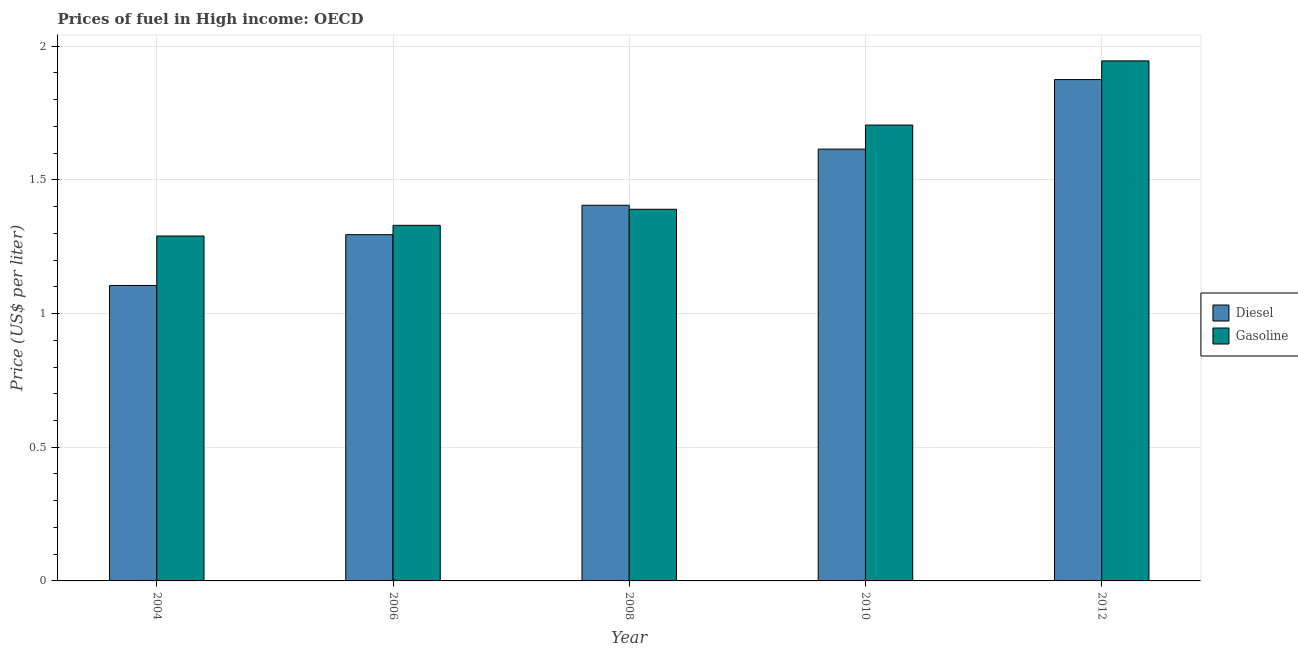How many different coloured bars are there?
Provide a short and direct response. 2. Are the number of bars per tick equal to the number of legend labels?
Your answer should be very brief. Yes. Are the number of bars on each tick of the X-axis equal?
Your answer should be very brief. Yes. How many bars are there on the 3rd tick from the left?
Offer a very short reply. 2. How many bars are there on the 2nd tick from the right?
Your answer should be compact. 2. What is the label of the 2nd group of bars from the left?
Your answer should be very brief. 2006. What is the diesel price in 2004?
Offer a terse response. 1.1. Across all years, what is the maximum gasoline price?
Provide a short and direct response. 1.95. Across all years, what is the minimum gasoline price?
Your answer should be compact. 1.29. In which year was the diesel price minimum?
Keep it short and to the point. 2004. What is the total diesel price in the graph?
Your response must be concise. 7.29. What is the difference between the diesel price in 2006 and that in 2010?
Offer a terse response. -0.32. What is the difference between the diesel price in 2006 and the gasoline price in 2008?
Your answer should be compact. -0.11. What is the average diesel price per year?
Your answer should be compact. 1.46. In the year 2010, what is the difference between the gasoline price and diesel price?
Keep it short and to the point. 0. What is the ratio of the diesel price in 2004 to that in 2006?
Ensure brevity in your answer.  0.85. What is the difference between the highest and the second highest gasoline price?
Provide a succinct answer. 0.24. What is the difference between the highest and the lowest diesel price?
Offer a very short reply. 0.77. In how many years, is the diesel price greater than the average diesel price taken over all years?
Provide a succinct answer. 2. Is the sum of the diesel price in 2008 and 2012 greater than the maximum gasoline price across all years?
Offer a terse response. Yes. What does the 1st bar from the left in 2012 represents?
Offer a terse response. Diesel. What does the 2nd bar from the right in 2006 represents?
Your response must be concise. Diesel. How many bars are there?
Your answer should be compact. 10. Are all the bars in the graph horizontal?
Your response must be concise. No. Does the graph contain any zero values?
Make the answer very short. No. Where does the legend appear in the graph?
Keep it short and to the point. Center right. How are the legend labels stacked?
Provide a succinct answer. Vertical. What is the title of the graph?
Offer a terse response. Prices of fuel in High income: OECD. Does "Crop" appear as one of the legend labels in the graph?
Make the answer very short. No. What is the label or title of the Y-axis?
Your response must be concise. Price (US$ per liter). What is the Price (US$ per liter) in Diesel in 2004?
Provide a short and direct response. 1.1. What is the Price (US$ per liter) of Gasoline in 2004?
Offer a very short reply. 1.29. What is the Price (US$ per liter) of Diesel in 2006?
Your response must be concise. 1.29. What is the Price (US$ per liter) of Gasoline in 2006?
Provide a succinct answer. 1.33. What is the Price (US$ per liter) of Diesel in 2008?
Keep it short and to the point. 1.41. What is the Price (US$ per liter) of Gasoline in 2008?
Provide a succinct answer. 1.39. What is the Price (US$ per liter) of Diesel in 2010?
Give a very brief answer. 1.61. What is the Price (US$ per liter) of Gasoline in 2010?
Your response must be concise. 1.71. What is the Price (US$ per liter) of Diesel in 2012?
Offer a terse response. 1.88. What is the Price (US$ per liter) of Gasoline in 2012?
Offer a terse response. 1.95. Across all years, what is the maximum Price (US$ per liter) of Diesel?
Give a very brief answer. 1.88. Across all years, what is the maximum Price (US$ per liter) in Gasoline?
Offer a very short reply. 1.95. Across all years, what is the minimum Price (US$ per liter) in Diesel?
Ensure brevity in your answer.  1.1. Across all years, what is the minimum Price (US$ per liter) of Gasoline?
Make the answer very short. 1.29. What is the total Price (US$ per liter) in Diesel in the graph?
Your answer should be very brief. 7.29. What is the total Price (US$ per liter) in Gasoline in the graph?
Give a very brief answer. 7.66. What is the difference between the Price (US$ per liter) in Diesel in 2004 and that in 2006?
Provide a short and direct response. -0.19. What is the difference between the Price (US$ per liter) in Gasoline in 2004 and that in 2006?
Keep it short and to the point. -0.04. What is the difference between the Price (US$ per liter) in Diesel in 2004 and that in 2008?
Provide a succinct answer. -0.3. What is the difference between the Price (US$ per liter) in Diesel in 2004 and that in 2010?
Make the answer very short. -0.51. What is the difference between the Price (US$ per liter) of Gasoline in 2004 and that in 2010?
Keep it short and to the point. -0.41. What is the difference between the Price (US$ per liter) in Diesel in 2004 and that in 2012?
Offer a very short reply. -0.77. What is the difference between the Price (US$ per liter) of Gasoline in 2004 and that in 2012?
Your answer should be very brief. -0.66. What is the difference between the Price (US$ per liter) in Diesel in 2006 and that in 2008?
Make the answer very short. -0.11. What is the difference between the Price (US$ per liter) of Gasoline in 2006 and that in 2008?
Your answer should be compact. -0.06. What is the difference between the Price (US$ per liter) in Diesel in 2006 and that in 2010?
Ensure brevity in your answer.  -0.32. What is the difference between the Price (US$ per liter) in Gasoline in 2006 and that in 2010?
Offer a terse response. -0.38. What is the difference between the Price (US$ per liter) in Diesel in 2006 and that in 2012?
Provide a succinct answer. -0.58. What is the difference between the Price (US$ per liter) of Gasoline in 2006 and that in 2012?
Your answer should be compact. -0.61. What is the difference between the Price (US$ per liter) in Diesel in 2008 and that in 2010?
Give a very brief answer. -0.21. What is the difference between the Price (US$ per liter) in Gasoline in 2008 and that in 2010?
Make the answer very short. -0.32. What is the difference between the Price (US$ per liter) in Diesel in 2008 and that in 2012?
Keep it short and to the point. -0.47. What is the difference between the Price (US$ per liter) of Gasoline in 2008 and that in 2012?
Your answer should be very brief. -0.56. What is the difference between the Price (US$ per liter) of Diesel in 2010 and that in 2012?
Ensure brevity in your answer.  -0.26. What is the difference between the Price (US$ per liter) in Gasoline in 2010 and that in 2012?
Keep it short and to the point. -0.24. What is the difference between the Price (US$ per liter) in Diesel in 2004 and the Price (US$ per liter) in Gasoline in 2006?
Give a very brief answer. -0.23. What is the difference between the Price (US$ per liter) in Diesel in 2004 and the Price (US$ per liter) in Gasoline in 2008?
Give a very brief answer. -0.28. What is the difference between the Price (US$ per liter) in Diesel in 2004 and the Price (US$ per liter) in Gasoline in 2012?
Offer a very short reply. -0.84. What is the difference between the Price (US$ per liter) of Diesel in 2006 and the Price (US$ per liter) of Gasoline in 2008?
Offer a terse response. -0.1. What is the difference between the Price (US$ per liter) of Diesel in 2006 and the Price (US$ per liter) of Gasoline in 2010?
Your answer should be compact. -0.41. What is the difference between the Price (US$ per liter) in Diesel in 2006 and the Price (US$ per liter) in Gasoline in 2012?
Provide a short and direct response. -0.65. What is the difference between the Price (US$ per liter) in Diesel in 2008 and the Price (US$ per liter) in Gasoline in 2010?
Provide a succinct answer. -0.3. What is the difference between the Price (US$ per liter) of Diesel in 2008 and the Price (US$ per liter) of Gasoline in 2012?
Your response must be concise. -0.54. What is the difference between the Price (US$ per liter) of Diesel in 2010 and the Price (US$ per liter) of Gasoline in 2012?
Your response must be concise. -0.33. What is the average Price (US$ per liter) of Diesel per year?
Ensure brevity in your answer.  1.46. What is the average Price (US$ per liter) of Gasoline per year?
Keep it short and to the point. 1.53. In the year 2004, what is the difference between the Price (US$ per liter) of Diesel and Price (US$ per liter) of Gasoline?
Ensure brevity in your answer.  -0.18. In the year 2006, what is the difference between the Price (US$ per liter) of Diesel and Price (US$ per liter) of Gasoline?
Your response must be concise. -0.04. In the year 2008, what is the difference between the Price (US$ per liter) of Diesel and Price (US$ per liter) of Gasoline?
Offer a terse response. 0.01. In the year 2010, what is the difference between the Price (US$ per liter) in Diesel and Price (US$ per liter) in Gasoline?
Your response must be concise. -0.09. In the year 2012, what is the difference between the Price (US$ per liter) of Diesel and Price (US$ per liter) of Gasoline?
Offer a very short reply. -0.07. What is the ratio of the Price (US$ per liter) in Diesel in 2004 to that in 2006?
Offer a terse response. 0.85. What is the ratio of the Price (US$ per liter) in Gasoline in 2004 to that in 2006?
Offer a terse response. 0.97. What is the ratio of the Price (US$ per liter) in Diesel in 2004 to that in 2008?
Your answer should be compact. 0.79. What is the ratio of the Price (US$ per liter) of Gasoline in 2004 to that in 2008?
Your answer should be very brief. 0.93. What is the ratio of the Price (US$ per liter) in Diesel in 2004 to that in 2010?
Your answer should be compact. 0.68. What is the ratio of the Price (US$ per liter) of Gasoline in 2004 to that in 2010?
Keep it short and to the point. 0.76. What is the ratio of the Price (US$ per liter) of Diesel in 2004 to that in 2012?
Offer a terse response. 0.59. What is the ratio of the Price (US$ per liter) in Gasoline in 2004 to that in 2012?
Offer a terse response. 0.66. What is the ratio of the Price (US$ per liter) of Diesel in 2006 to that in 2008?
Offer a terse response. 0.92. What is the ratio of the Price (US$ per liter) of Gasoline in 2006 to that in 2008?
Keep it short and to the point. 0.96. What is the ratio of the Price (US$ per liter) in Diesel in 2006 to that in 2010?
Give a very brief answer. 0.8. What is the ratio of the Price (US$ per liter) in Gasoline in 2006 to that in 2010?
Keep it short and to the point. 0.78. What is the ratio of the Price (US$ per liter) of Diesel in 2006 to that in 2012?
Your answer should be compact. 0.69. What is the ratio of the Price (US$ per liter) of Gasoline in 2006 to that in 2012?
Give a very brief answer. 0.68. What is the ratio of the Price (US$ per liter) in Diesel in 2008 to that in 2010?
Provide a succinct answer. 0.87. What is the ratio of the Price (US$ per liter) of Gasoline in 2008 to that in 2010?
Give a very brief answer. 0.82. What is the ratio of the Price (US$ per liter) in Diesel in 2008 to that in 2012?
Provide a short and direct response. 0.75. What is the ratio of the Price (US$ per liter) of Gasoline in 2008 to that in 2012?
Your answer should be very brief. 0.71. What is the ratio of the Price (US$ per liter) of Diesel in 2010 to that in 2012?
Make the answer very short. 0.86. What is the ratio of the Price (US$ per liter) in Gasoline in 2010 to that in 2012?
Give a very brief answer. 0.88. What is the difference between the highest and the second highest Price (US$ per liter) of Diesel?
Offer a very short reply. 0.26. What is the difference between the highest and the second highest Price (US$ per liter) of Gasoline?
Offer a very short reply. 0.24. What is the difference between the highest and the lowest Price (US$ per liter) in Diesel?
Your answer should be very brief. 0.77. What is the difference between the highest and the lowest Price (US$ per liter) in Gasoline?
Provide a short and direct response. 0.66. 